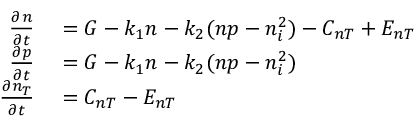<formula> <loc_0><loc_0><loc_500><loc_500>\begin{array} { r l } { \frac { \partial n } { \partial t } } & = G - k _ { 1 } n - k _ { 2 } ( n p - n _ { i } ^ { 2 } ) - C _ { n T } + E _ { n T } } \\ { \frac { \partial p } { \partial t } } & = G - k _ { 1 } n - k _ { 2 } ( n p - n _ { i } ^ { 2 } ) } \\ { \frac { \partial n _ { T } } { \partial t } } & = C _ { n T } - E _ { n T } } \end{array}</formula> 